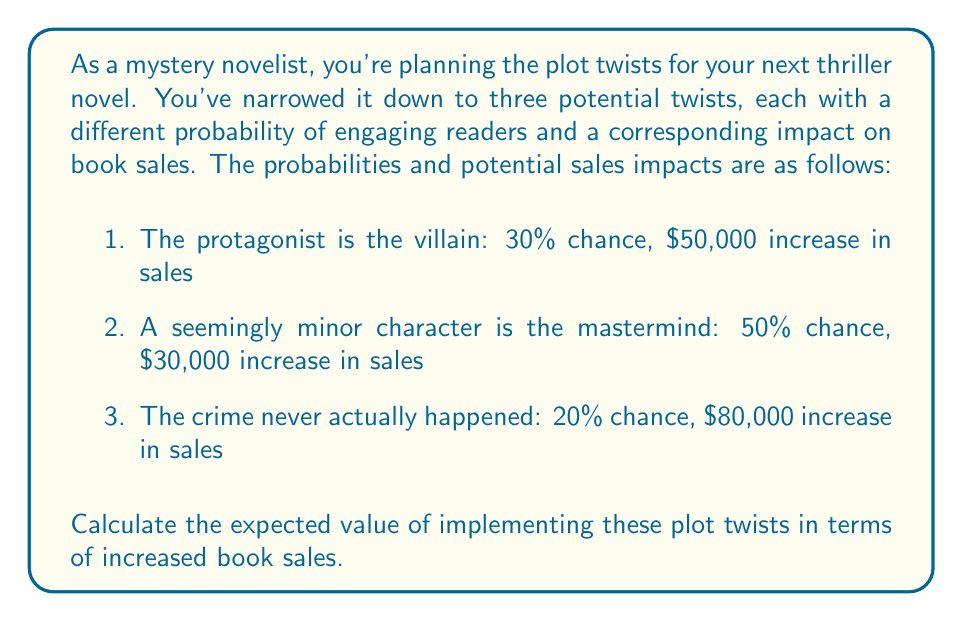Teach me how to tackle this problem. To solve this problem, we need to use the concept of expected value from decision theory. The expected value is calculated by multiplying each possible outcome by its probability of occurrence and then summing these products.

Let's break down the calculation for each plot twist:

1. Protagonist as villain:
   Probability = 30% = 0.3
   Sales increase = $50,000
   Expected value = $50,000 * 0.3 = $15,000

2. Minor character as mastermind:
   Probability = 50% = 0.5
   Sales increase = $30,000
   Expected value = $30,000 * 0.5 = $15,000

3. Crime never happened:
   Probability = 20% = 0.2
   Sales increase = $80,000
   Expected value = $80,000 * 0.2 = $16,000

Now, we can express this mathematically using the expected value formula:

$$E(X) = \sum_{i=1}^{n} p_i x_i$$

Where:
$E(X)$ is the expected value
$p_i$ is the probability of each outcome
$x_i$ is the value of each outcome

Plugging in our values:

$$E(X) = (0.3 * 50000) + (0.5 * 30000) + (0.2 * 80000)$$

$$E(X) = 15000 + 15000 + 16000$$

$$E(X) = 46000$$

Therefore, the expected value of implementing these plot twists is $46,000 in increased book sales.
Answer: $46,000 